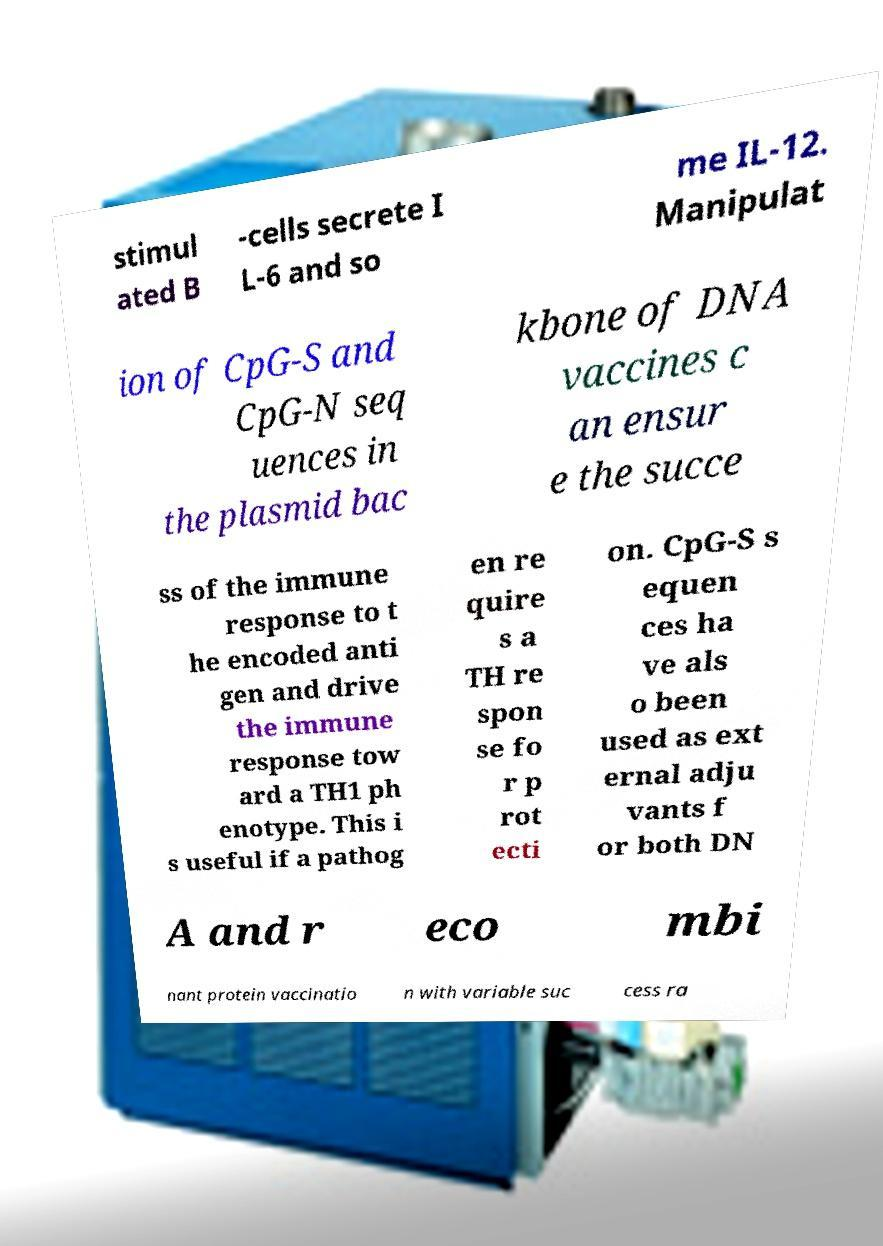Please identify and transcribe the text found in this image. stimul ated B -cells secrete I L-6 and so me IL-12. Manipulat ion of CpG-S and CpG-N seq uences in the plasmid bac kbone of DNA vaccines c an ensur e the succe ss of the immune response to t he encoded anti gen and drive the immune response tow ard a TH1 ph enotype. This i s useful if a pathog en re quire s a TH re spon se fo r p rot ecti on. CpG-S s equen ces ha ve als o been used as ext ernal adju vants f or both DN A and r eco mbi nant protein vaccinatio n with variable suc cess ra 